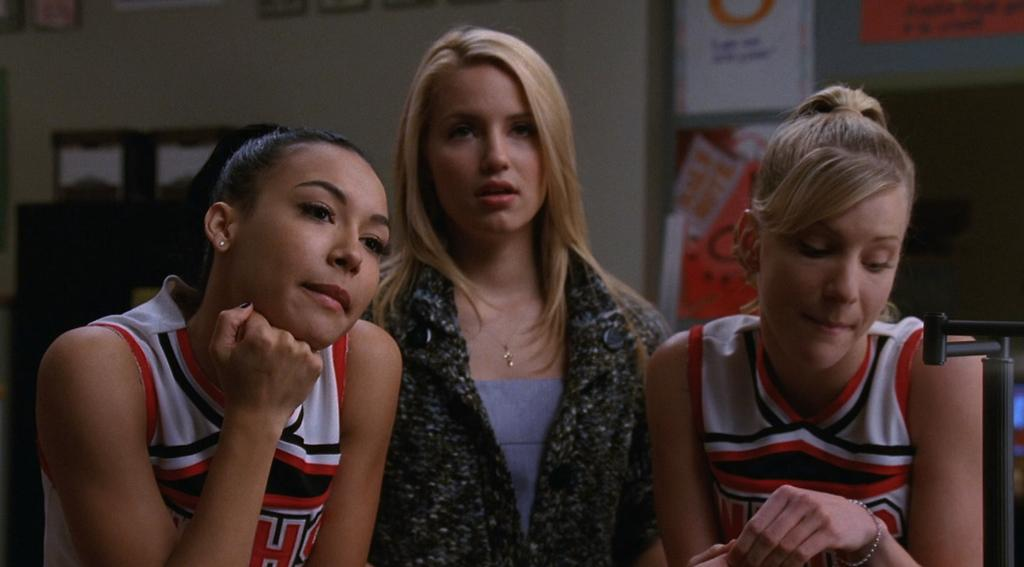<image>
Give a short and clear explanation of the subsequent image. Three girls stand next to each other one, with an H on her cheer uniform 